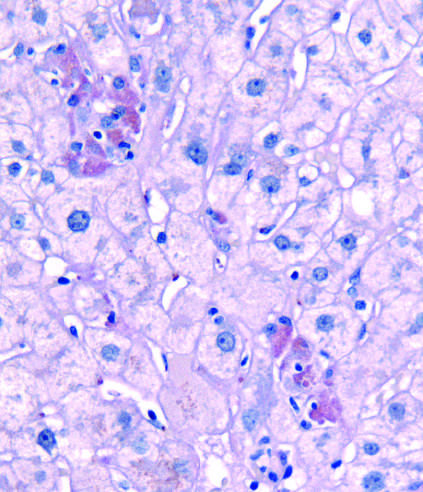do clusters of pigmented hepatocytes with eosinophilic cytoplasm indicate foci of hepatocytes undergoing necrosis in this pas-d-stained biopsy from a patient with acute hepatitis b?
Answer the question using a single word or phrase. Yes 